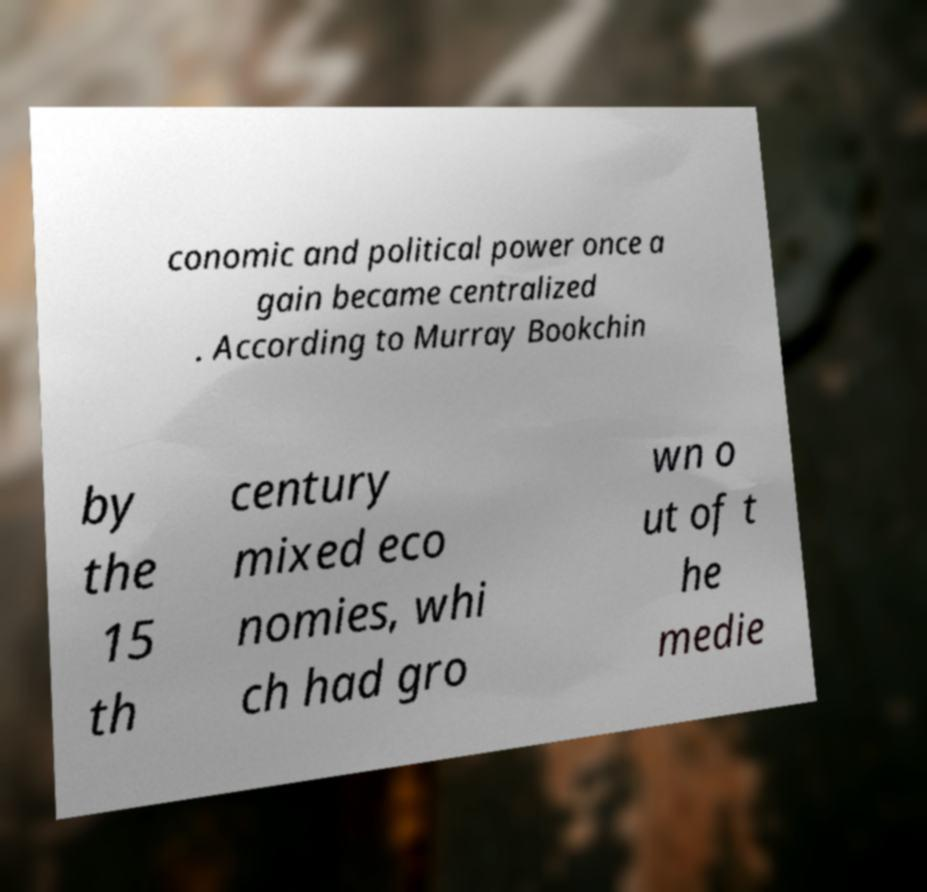Could you extract and type out the text from this image? conomic and political power once a gain became centralized . According to Murray Bookchin by the 15 th century mixed eco nomies, whi ch had gro wn o ut of t he medie 